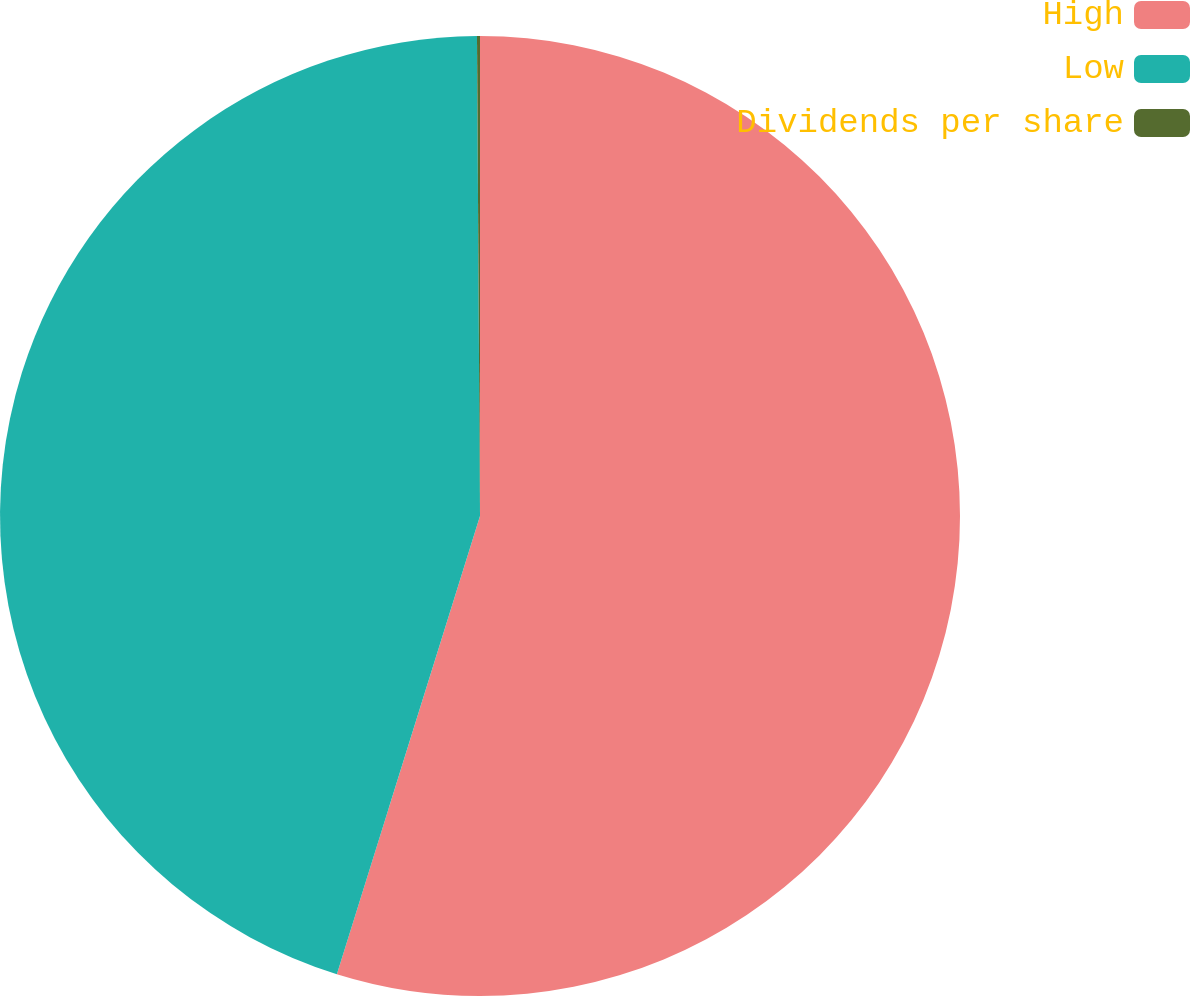Convert chart to OTSL. <chart><loc_0><loc_0><loc_500><loc_500><pie_chart><fcel>High<fcel>Low<fcel>Dividends per share<nl><fcel>54.82%<fcel>45.08%<fcel>0.1%<nl></chart> 